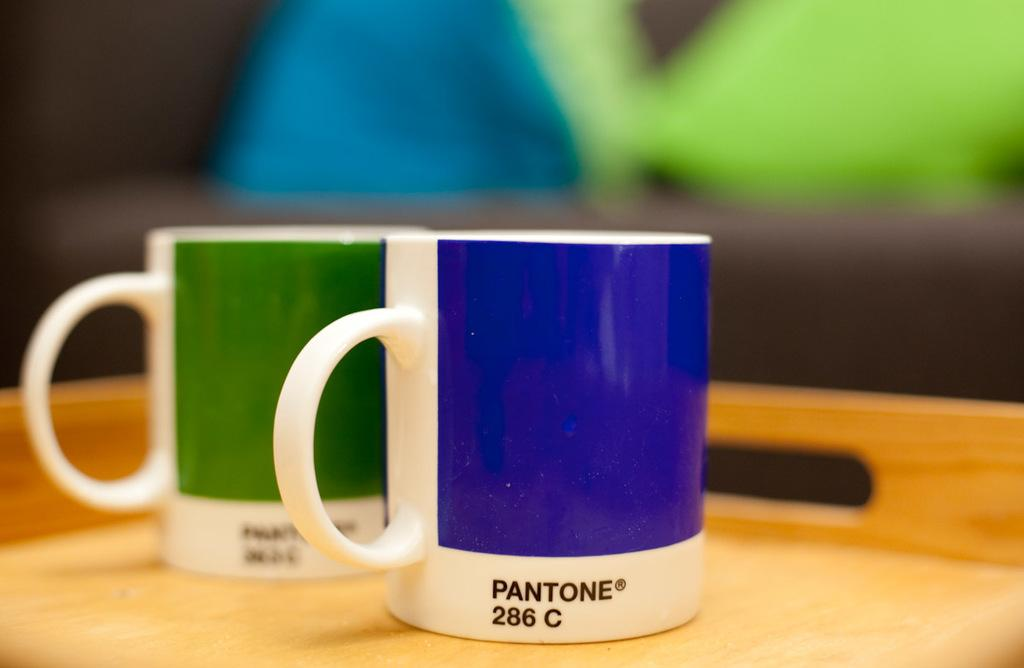What objects are present in the image related to coffee? There are two coffee mugs in the image. How are the coffee mugs arranged or positioned in the image? The coffee mugs are placed on a tray. What type of coach can be seen in the image? There is no coach present in the image. Are there any goldfish swimming in the coffee mugs in the image? There are no goldfish present in the image, and the coffee mugs are not filled with water for fish to swim in. 